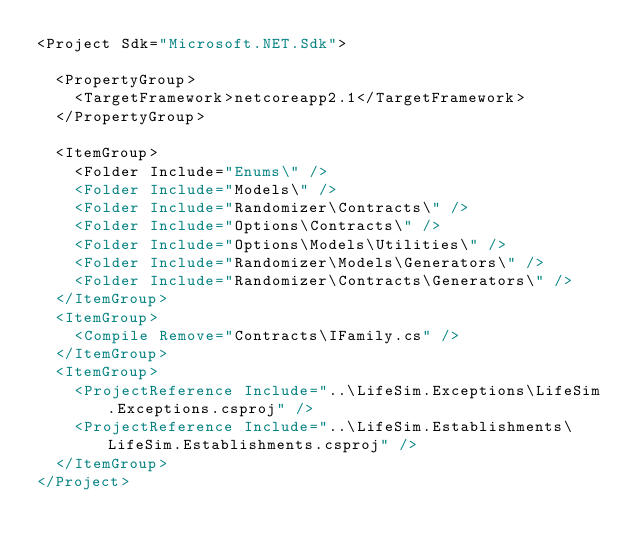Convert code to text. <code><loc_0><loc_0><loc_500><loc_500><_XML_><Project Sdk="Microsoft.NET.Sdk">

  <PropertyGroup>
    <TargetFramework>netcoreapp2.1</TargetFramework>
  </PropertyGroup>

  <ItemGroup>
    <Folder Include="Enums\" />
    <Folder Include="Models\" />
    <Folder Include="Randomizer\Contracts\" />
    <Folder Include="Options\Contracts\" />
    <Folder Include="Options\Models\Utilities\" />
    <Folder Include="Randomizer\Models\Generators\" />
    <Folder Include="Randomizer\Contracts\Generators\" />
  </ItemGroup>
  <ItemGroup>
    <Compile Remove="Contracts\IFamily.cs" />
  </ItemGroup>
  <ItemGroup>
    <ProjectReference Include="..\LifeSim.Exceptions\LifeSim.Exceptions.csproj" />
    <ProjectReference Include="..\LifeSim.Establishments\LifeSim.Establishments.csproj" />
  </ItemGroup>
</Project>
</code> 